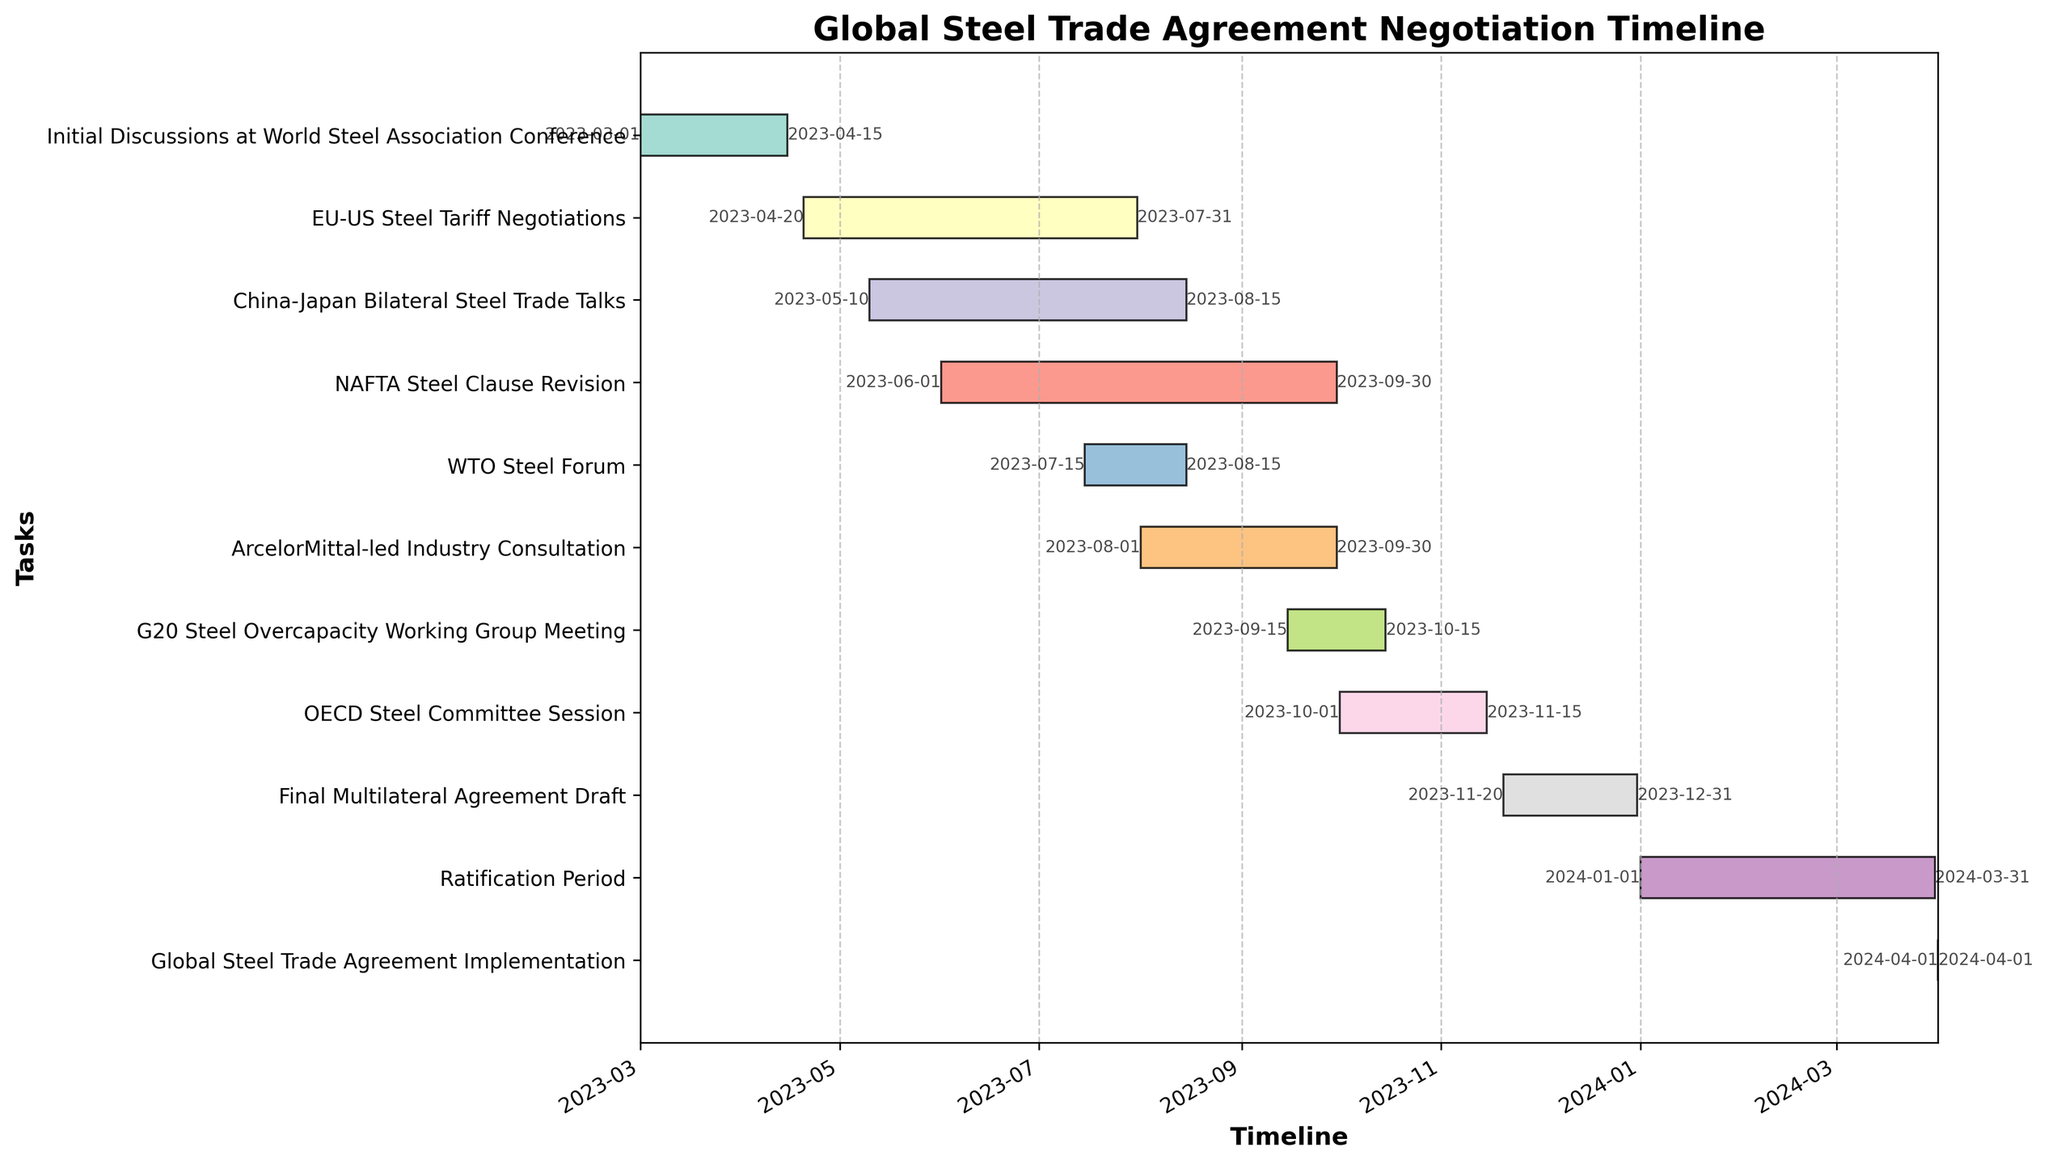How many tasks are listed in the Global Steel Trade Agreement Negotiation Timeline? Count the number of bars on the Gantt chart, each representing a task.
Answer: 11 When do the Initial Discussions at World Steel Association Conference start and end? Refer to the annotated start and end dates for the "Initial Discussions at World Steel Association Conference" bar.
Answer: 2023-03-01 to 2023-04-15 Which task has the longest duration? Compare the lengths of the bars to identify the one that spans the most days.
Answer: NAFTA Steel Clause Revision Which two tasks are scheduled to finish last in 2023? Look at the end dates of all tasks and identify the two that finish last before 2023 ends.
Answer: Final Multilateral Agreement Draft and ArcelorMittal-led Industry Consultation Are there any tasks that end on the same date? Identify bars that have the same end-date labels.
Answer: WTO Steel Forum and China-Japan Bilateral Steel Trade Talks Calculate the total duration (in days) covered by the EU-US Steel Tariff Negotiations and the China-Japan Bilateral Steel Trade Talks combined. The EU-US Steel Tariff Negotiations span from 2023-04-20 to 2023-07-31 (102 days) and the China-Japan Bilateral Steel Trade Talks span from 2023-05-10 to 2023-08-15 (97 days). Sum their durations: 102 + 97.
Answer: 199 days Which task(s) overlap with the WTO Steel Forum? Identify tasks whose start and/or end dates fall between 2023-07-15 and 2023-08-15.
Answer: China-Japan Bilateral Steel Trade Talks, EU-US Steel Tariff Negotiations, ArcelorMittal-led Industry Consultation When does the Ratification Period begin, and how long does it last? Check the start and duration annotations for the "Ratification Period" bar. It starts on 2024-01-01 and ends on 2024-03-31.
Answer: 2024-01-01, 90 days What is the primary time gap between the end of the Ratification Period and the start of the Global Steel Trade Agreement Implementation? Examine the end date of the Ratification Period and the start date of the Global Steel Trade Agreement Implementation to identify the gap.
Answer: No gap, both occur on the same day (2024-04-01) Compare the durations of the ArcelorMittal-led Industry Consultation and G20 Steel Overcapacity Working Group Meeting. Calculate the difference between their start and end dates: ArcelorMittal-led Industry Consultation (2023-08-01 to 2023-09-30) lasts 61 days; G20 Steel Overcapacity Working Group Meeting (2023-09-15 to 2023-10-15) lasts 30 days.
Answer: ArcelorMittal-led Industry Consultation is longer by 31 days 